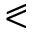Convert formula to latex. <formula><loc_0><loc_0><loc_500><loc_500>\ e q s l a n t l e s s</formula> 